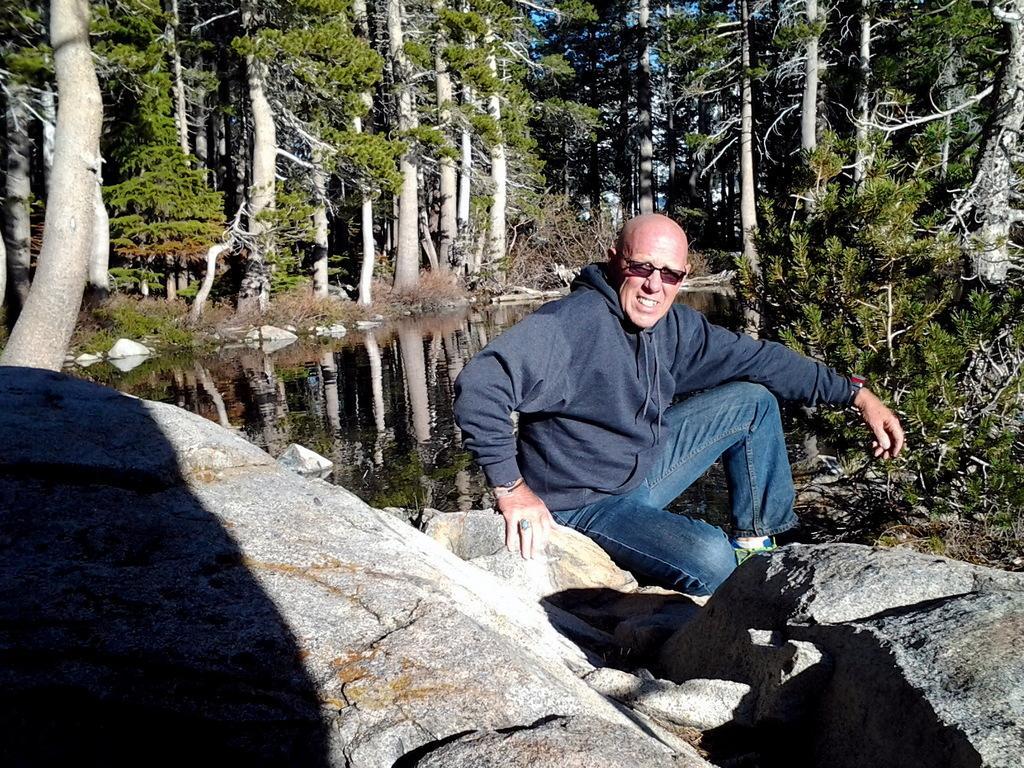In one or two sentences, can you explain what this image depicts? In the image we can see a man wearing clothes, shoes, finger ring, wrist watch and goggles and he is sitting. Here we can see stones, rock, water and the trees. 